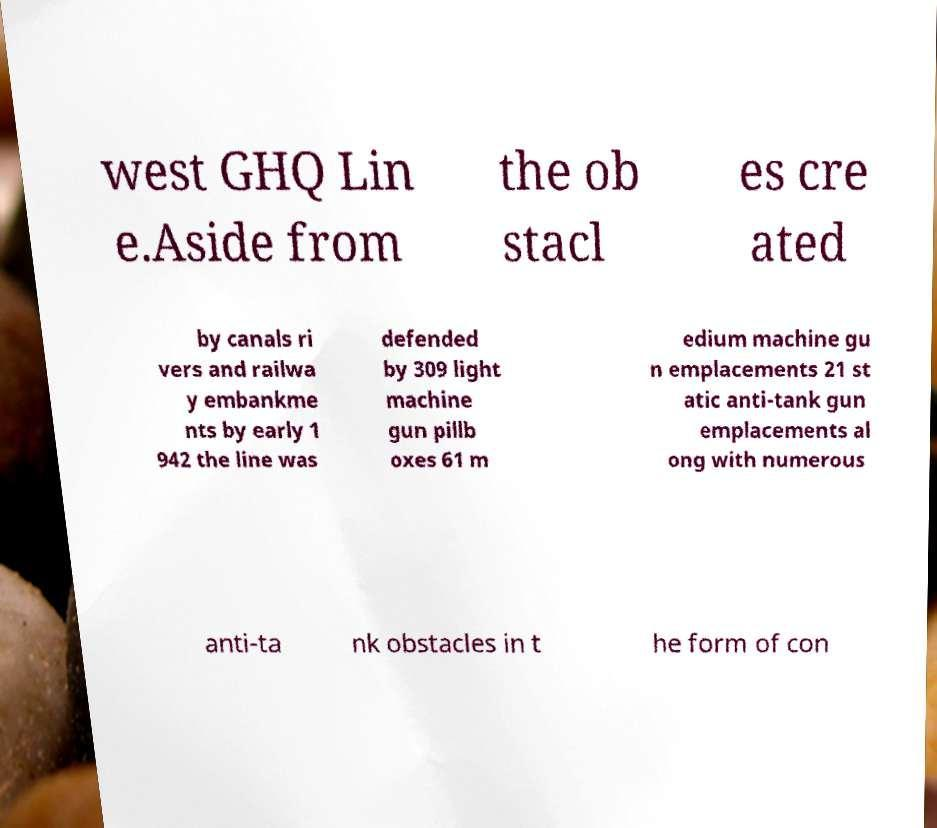Please read and relay the text visible in this image. What does it say? west GHQ Lin e.Aside from the ob stacl es cre ated by canals ri vers and railwa y embankme nts by early 1 942 the line was defended by 309 light machine gun pillb oxes 61 m edium machine gu n emplacements 21 st atic anti-tank gun emplacements al ong with numerous anti-ta nk obstacles in t he form of con 